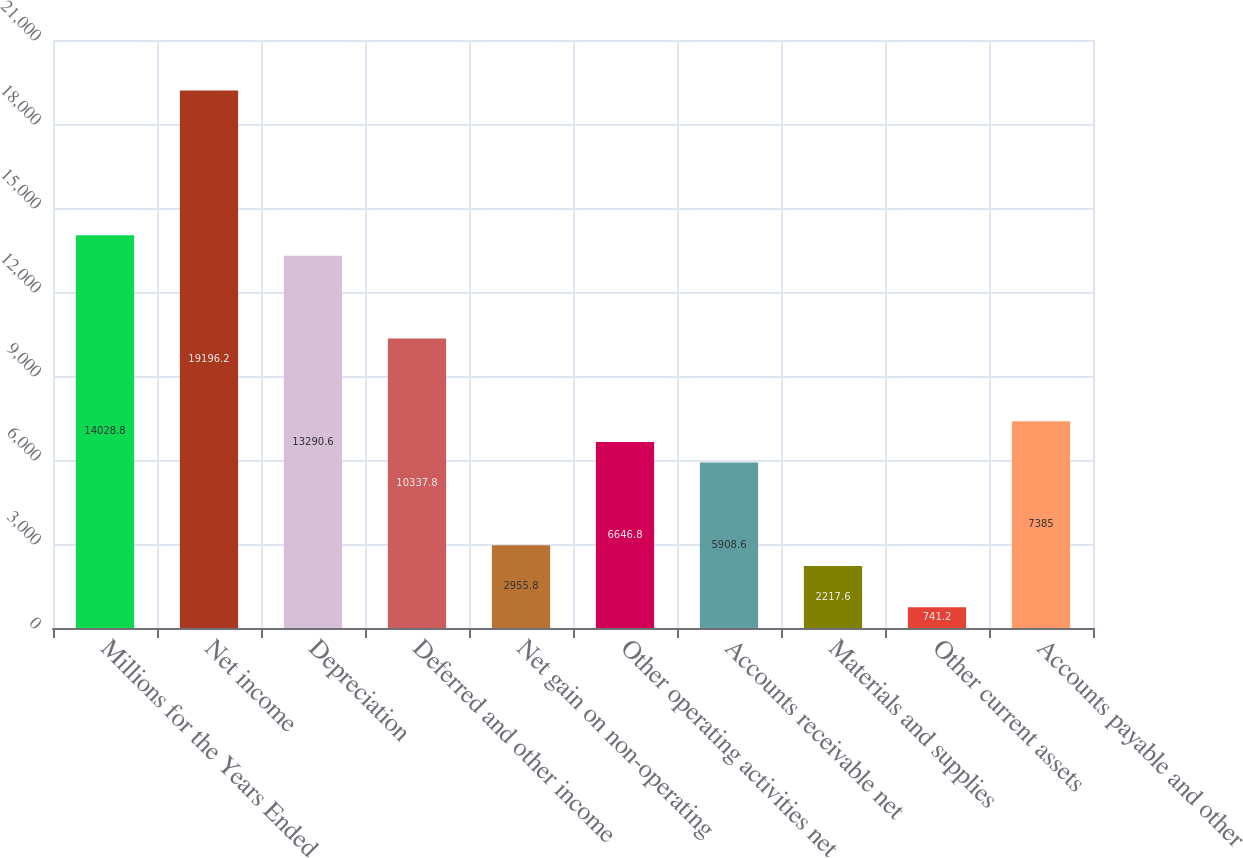Convert chart to OTSL. <chart><loc_0><loc_0><loc_500><loc_500><bar_chart><fcel>Millions for the Years Ended<fcel>Net income<fcel>Depreciation<fcel>Deferred and other income<fcel>Net gain on non-operating<fcel>Other operating activities net<fcel>Accounts receivable net<fcel>Materials and supplies<fcel>Other current assets<fcel>Accounts payable and other<nl><fcel>14028.8<fcel>19196.2<fcel>13290.6<fcel>10337.8<fcel>2955.8<fcel>6646.8<fcel>5908.6<fcel>2217.6<fcel>741.2<fcel>7385<nl></chart> 